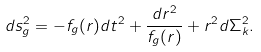<formula> <loc_0><loc_0><loc_500><loc_500>d s ^ { 2 } _ { g } = - f _ { g } ( r ) d t ^ { 2 } + \frac { d r ^ { 2 } } { f _ { g } ( r ) } + r ^ { 2 } d \Sigma _ { k } ^ { 2 } .</formula> 